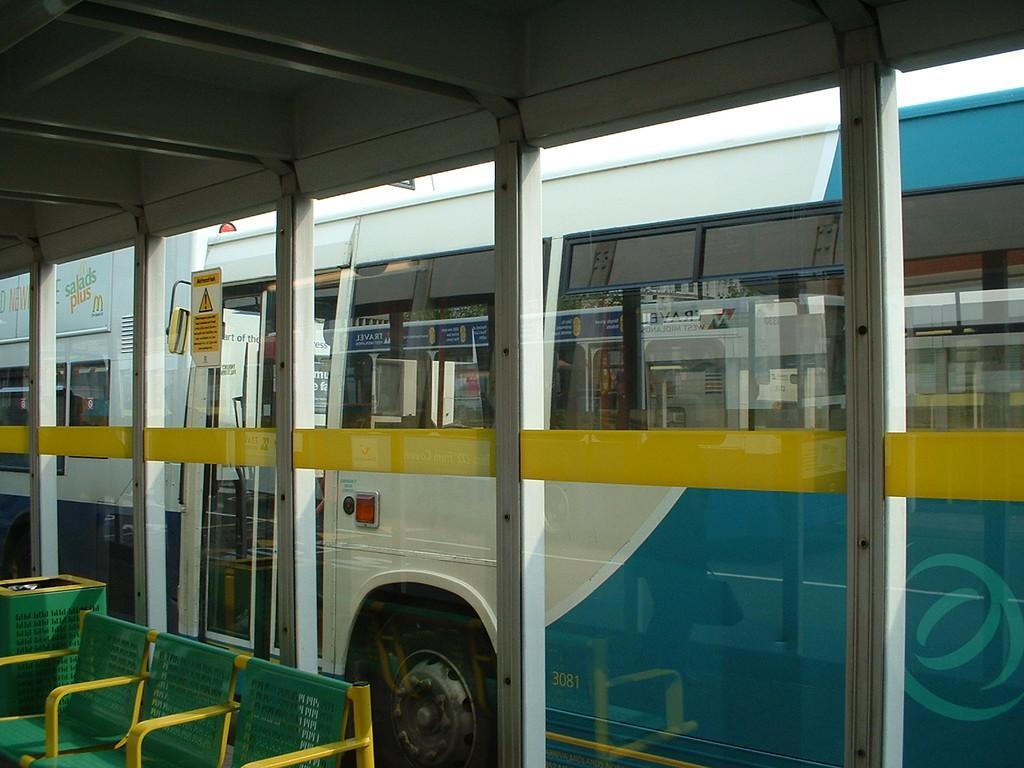Could you give a brief overview of what you see in this image? In this image we can see a bus from a window. We can also see some chairs and a dustbin. 